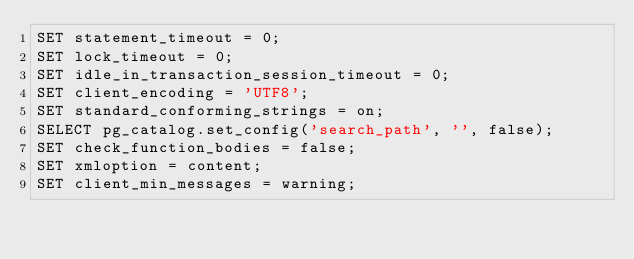<code> <loc_0><loc_0><loc_500><loc_500><_SQL_>SET statement_timeout = 0;
SET lock_timeout = 0;
SET idle_in_transaction_session_timeout = 0;
SET client_encoding = 'UTF8';
SET standard_conforming_strings = on;
SELECT pg_catalog.set_config('search_path', '', false);
SET check_function_bodies = false;
SET xmloption = content;
SET client_min_messages = warning;</code> 